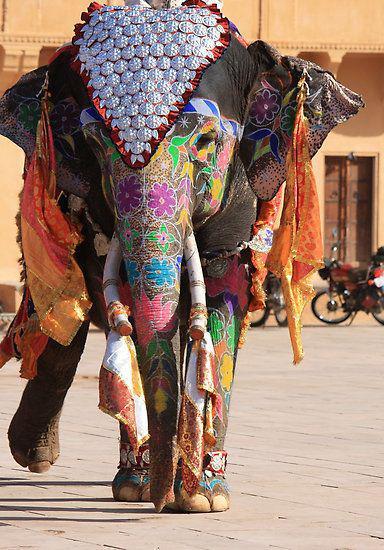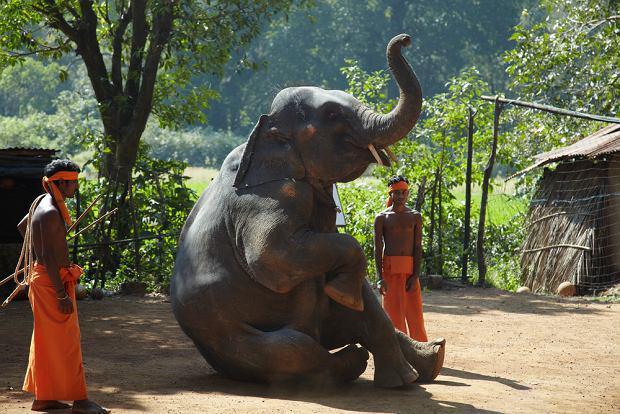The first image is the image on the left, the second image is the image on the right. For the images displayed, is the sentence "At least one person is standing near an elephant in the image on the right." factually correct? Answer yes or no. Yes. The first image is the image on the left, the second image is the image on the right. Examine the images to the left and right. Is the description "One elephant wears primarily orange decorations and has something trimmed with bell shapes around its neck." accurate? Answer yes or no. No. The first image is the image on the left, the second image is the image on the right. Considering the images on both sides, is "An image shows a camera-facing tusked elephant wearing an ornate dimensional metallic-look head covering." valid? Answer yes or no. Yes. The first image is the image on the left, the second image is the image on the right. Assess this claim about the two images: "An elephant in one image is wearing a colorful head cloth that descends over its forehead to a point between its eyes, so that its eyes are still visible". Correct or not? Answer yes or no. Yes. 